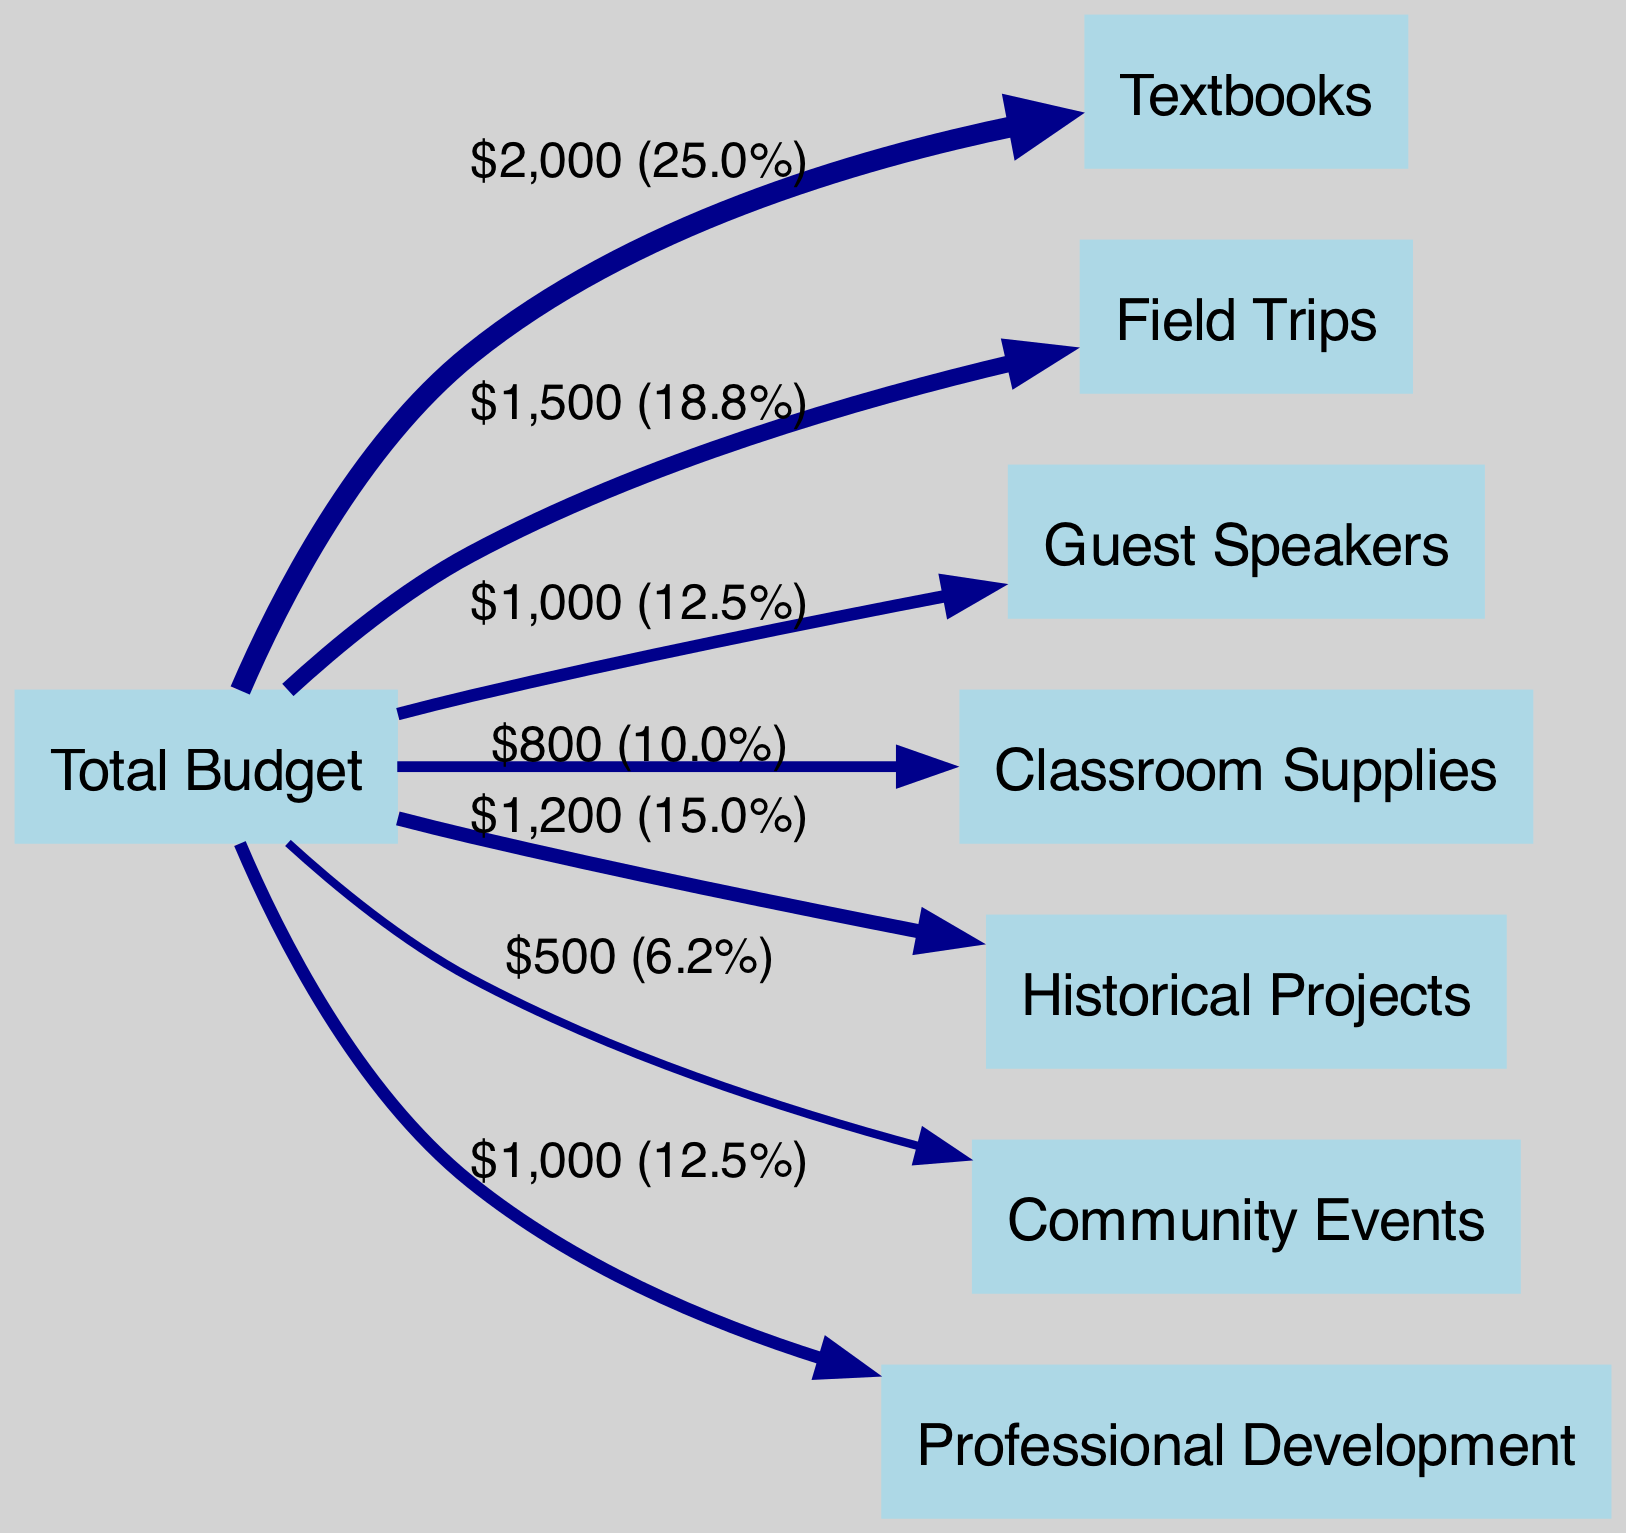What is the total amount allocated to textbooks? The diagram indicates that the link between "Total Budget" and "Textbooks" has a value of $2000, which shows the specific allocation for textbooks in the budget.
Answer: $2000 How much funding is designated for field trips? By observing the link from "Total Budget" to "Field Trips," we see that the value assigned is $1500, indicating the funding allocated for field trips.
Answer: $1500 Which activity receives the least amount of funding? The diagram shows that "Community Events" is connected to "Total Budget" with a value of $500, which is lower than all other allocations.
Answer: Community Events What percentage of the total budget is allocated to guest speakers? To find the percentage, we first calculate the total budget sum, which is $7000. The guest speakers receive $1000, so the percentage is calculated as (1000/7000) * 100 = 14.3%.
Answer: 14.3% What is the total budget allocation across all activities? By summing all the values connected to "Total Budget" (2000 for Textbooks, 1500 for Field Trips, 1000 for Guest Speakers, 800 for Classroom Supplies, 1200 for Historical Projects, 500 for Community Events, and 1000 for Professional Development), we find the total is $7000.
Answer: $7000 Which two activities receive the highest allocations, and what are their amounts? The diagram clearly shows that "Textbooks" and "Field Trips" connect to "Total Budget" with the highest amounts of $2000 and $1500, respectively, making them the top two allocations.
Answer: Textbooks ($2000), Field Trips ($1500) How does the funding for historical projects compare to that for classroom supplies? The amounts for these two activities are $1200 for "Historical Projects" and $800 for "Classroom Supplies." Comparing these, historical projects receive more funding.
Answer: Historical Projects (more) Is the amount allocated for professional development higher or lower than that allocated for guest speakers? The value for "Professional Development" is $1000, which is the same as "Guest Speakers," which is also $1000. Therefore, neither is higher or lower; they are equal.
Answer: Equal What proportion of the total budget is assigned to historical projects? Historical projects receive $1200, and the total budget is $7000. The proportion can be calculated as ($1200/$7000) * 100 = 17.1%.
Answer: 17.1% 